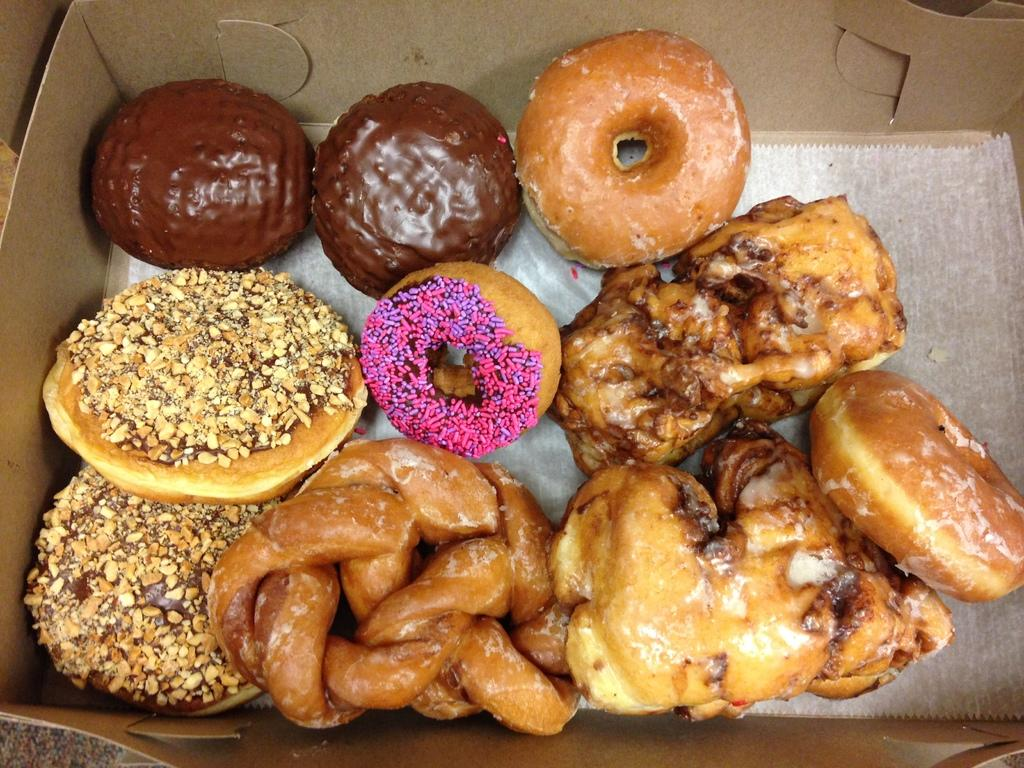What object is present in the image? There is a box in the image. What is inside the box? The box contains sweets. What is the position of the steel head in the image? There is no steel head present in the image. 